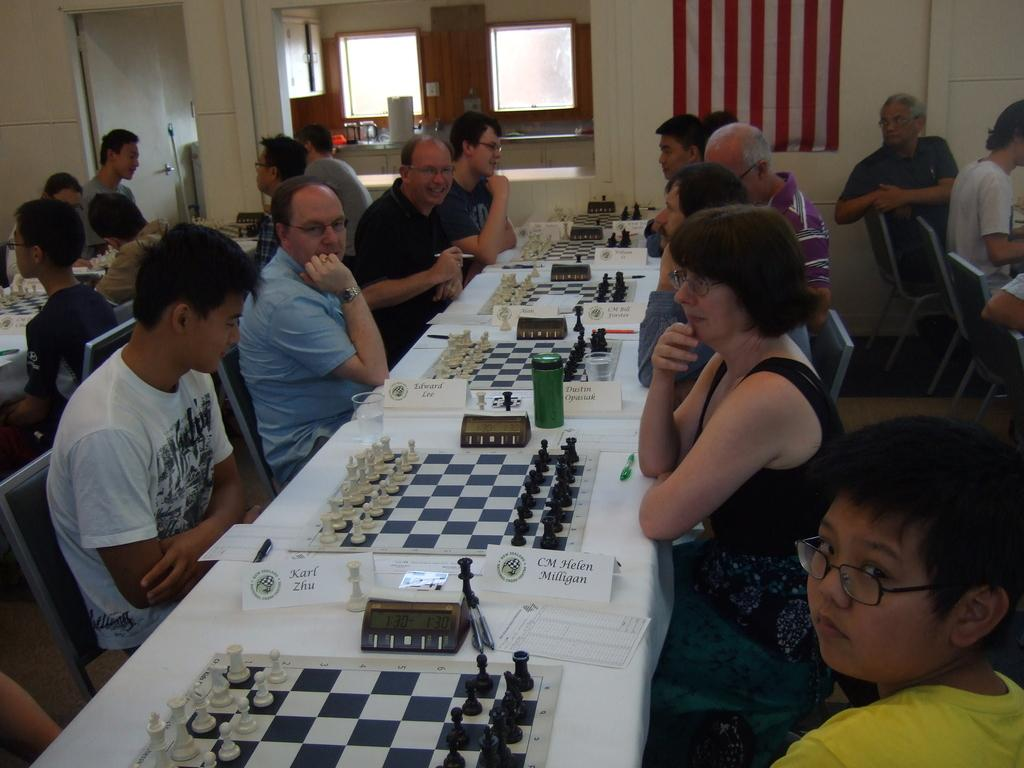What can be seen through the window in the image? The image does not show what can be seen through the window. Where is the flag located in the image? The flag is in the image, but its exact location is not specified. What type of structure is visible in the image? There is a wall visible in the image, which suggests a building or room. What are the people in the image doing? The people in the image are sitting, but their specific activities are not mentioned. What type of furniture is present in the image? Chairs and tables are present in the image. What is on the table with the chess board? Coins are on a table in the image. What type of texture can be seen on the kite in the image? There is no kite present in the image. Is there a jail visible in the image? There is no mention of a jail in the image. 